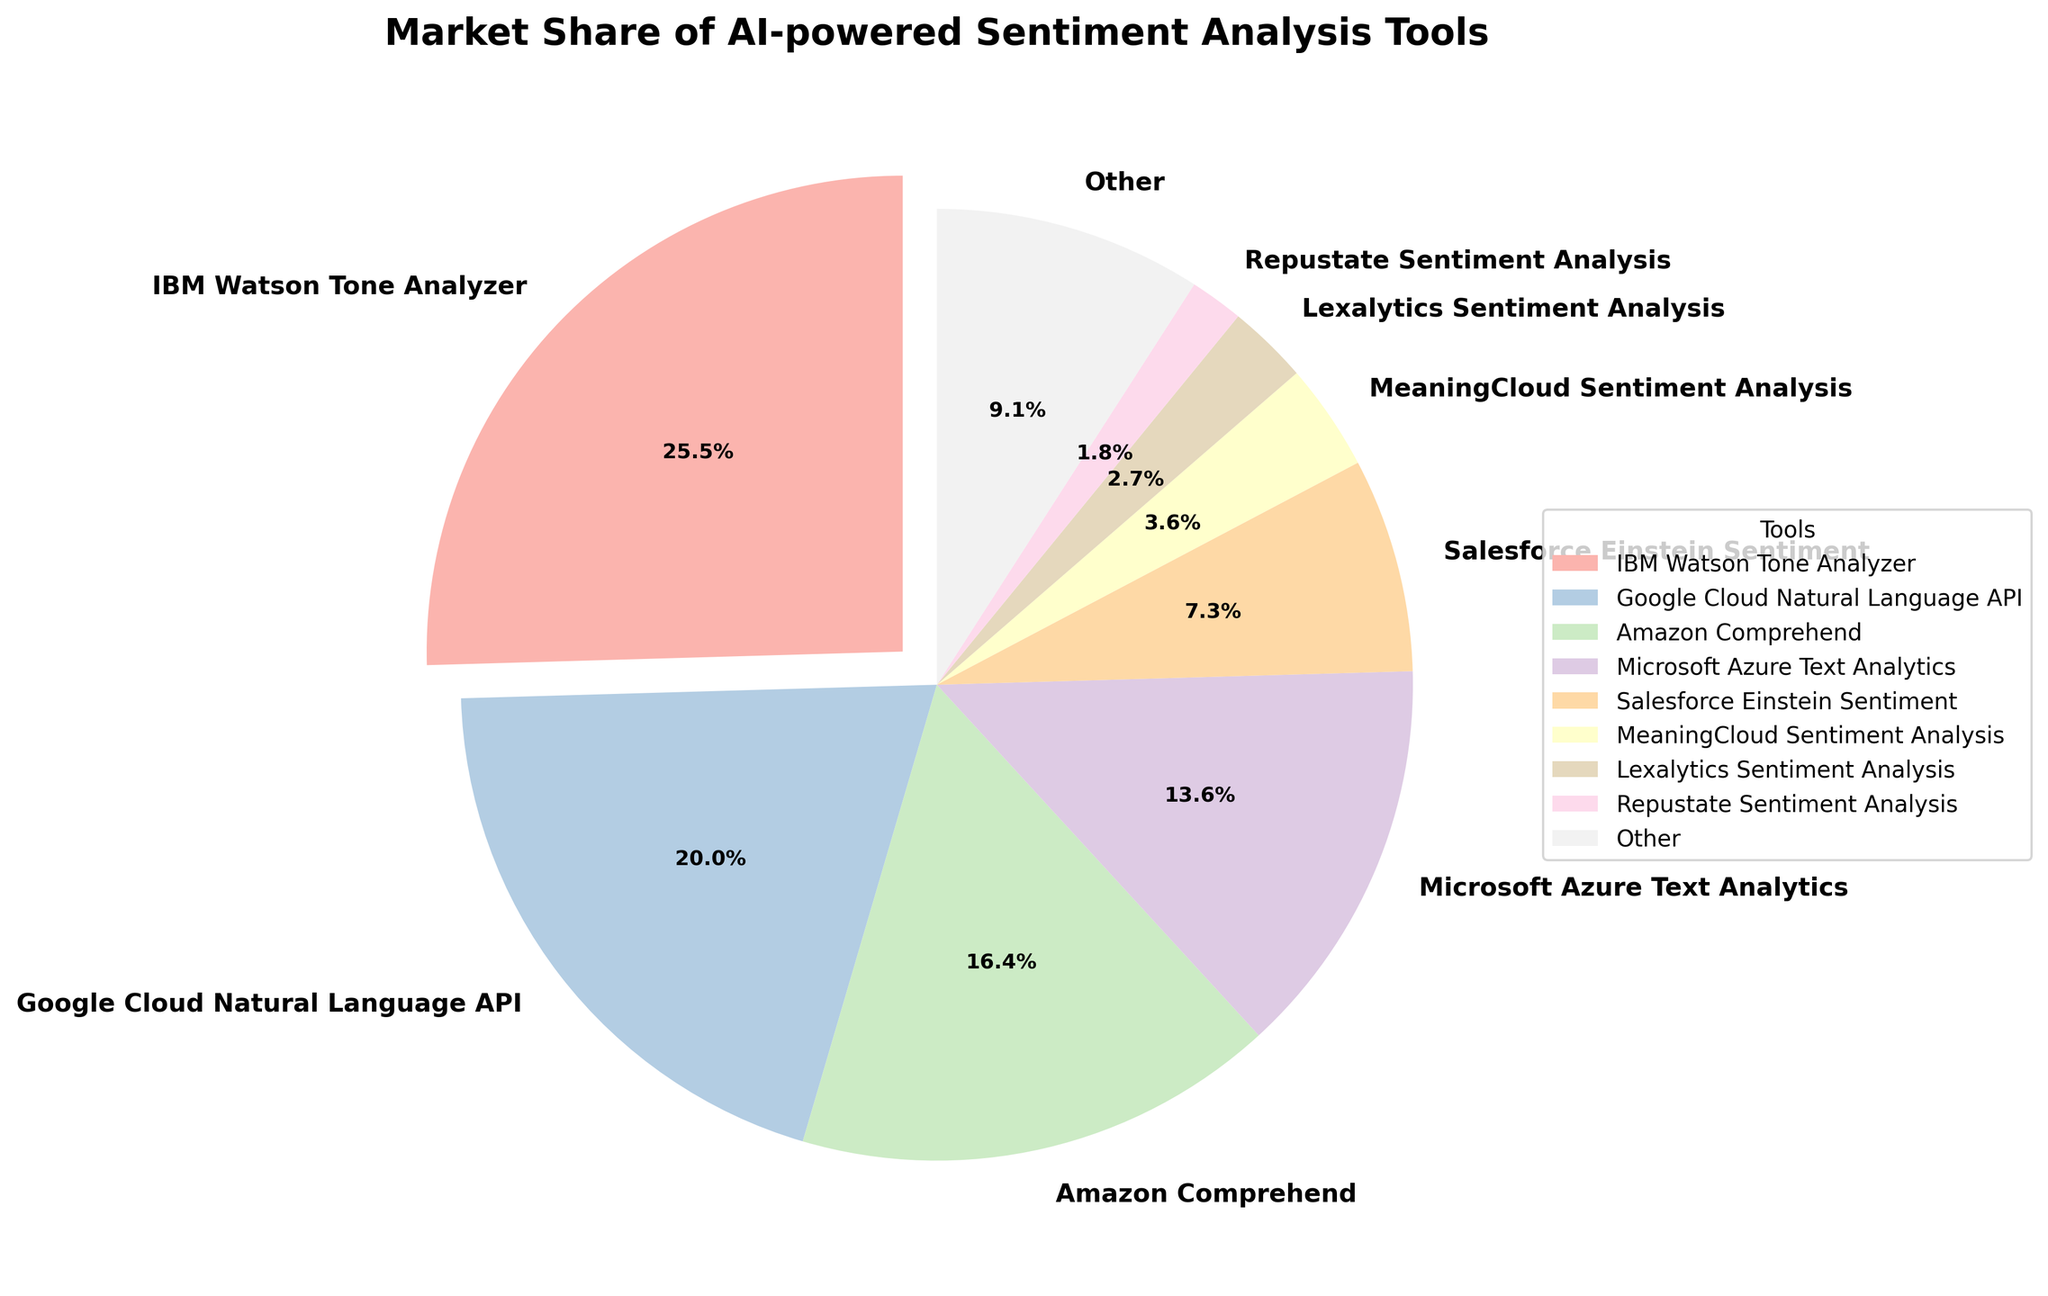What percentage of the market share does IBM Watson Tone Analyzer hold? IBM Watson Tone Analyzer holds 28% of the market share according to the figure.
Answer: 28% Which tool has a smaller market share, Microsoft Azure Text Analytics or Amazon Comprehend? Microsoft Azure Text Analytics has a market share of 15%, while Amazon Comprehend has a market share of 18%. Therefore, Microsoft Azure Text Analytics has a smaller market share.
Answer: Microsoft Azure Text Analytics What is the total market share of Salesforce Einstein Sentiment and MeaningCloud Sentiment Analysis combined? Salesforce Einstein Sentiment has a market share of 8%, and MeaningCloud Sentiment Analysis has 4%. Their combined market share is \(8\% + 4\% = 12\%\).
Answer: 12% Which tools together hold more market share: Google Cloud Natural Language API and IBM Watson Tone Analyzer, or the sum of all others excluding IBM Watson Tone Analyzer? Google Cloud Natural Language API has 22% and IBM Watson Tone Analyzer has 28%, summing to \(22\% + 28\% = 50\%\). The sum of the other tools excluding IBM is \(100\% - 28\% = 72\%\).
Answer: The sum of all others excluding IBM Watson Tone Analyzer What is the difference in market share between the largest and smallest market share tool in the figure? The tool with the largest market share is IBM Watson Tone Analyzer at 28%. The tool with the smallest market share is Repustate Sentiment Analysis at 2%. The difference is \(28\% - 2\% = 26\%\).
Answer: 26% Is MeaningCloud Sentiment Analysis's market share greater than Lexalytics Sentiment Analysis's market share? MeaningCloud Sentiment Analysis has a market share of 4%, while Lexalytics Sentiment Analysis has 3%. Therefore, MeaningCloud Sentiment Analysis's market share is greater.
Answer: Yes Which tool's market share is visually indicated by an exploding slice in the pie chart? The slice representing IBM Watson Tone Analyzer is exploded to highlight it, indicating its 28% market share visually.
Answer: IBM Watson Tone Analyzer What is the combined market share of all tools with market shares less than or equal to 8%? Salesforce Einstein Sentiment has 8%, MeaningCloud Sentiment Analysis has 4%, Lexalytics Sentiment Analysis has 3%, and Repustate Sentiment Analysis has 2%. Their combined market share is \(8\% + 4\% + 3\% + 2\% = 17\%\).
Answer: 17% 